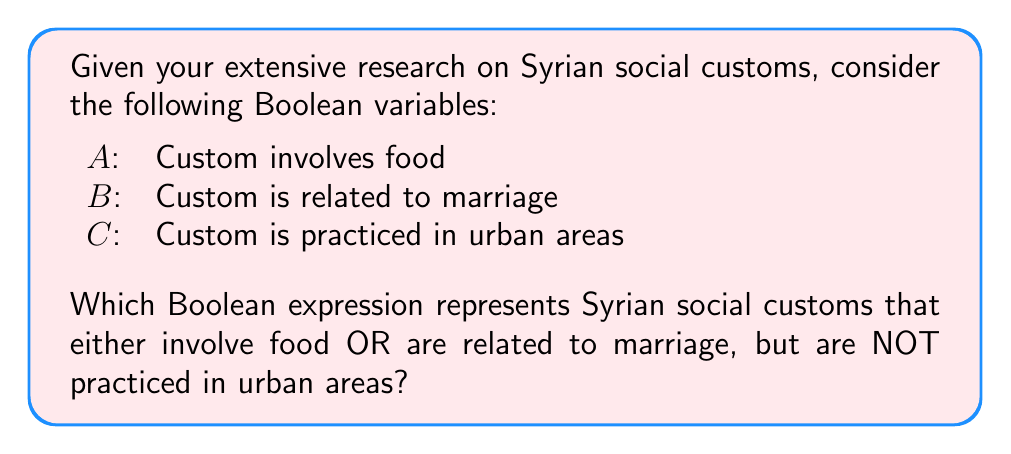Solve this math problem. Let's approach this step-by-step using Boolean algebra:

1) We need customs that involve food OR are related to marriage:
   This is represented by $(A \lor B)$

2) However, we don't want customs practiced in urban areas:
   This is represented by $\lnot C$ (NOT C)

3) We need to combine these conditions using AND:
   $$(A \lor B) \land \lnot C$$

4) This expression can be expanded using the distributive property:
   $$(A \land \lnot C) \lor (B \land \lnot C)$$

5) Interpretation:
   - $(A \land \lnot C)$ represents customs that involve food and are not practiced in urban areas
   - $(B \land \lnot C)$ represents customs related to marriage and not practiced in urban areas
   - The OR $\lor$ between these terms means we're including both types

This Boolean expression effectively classifies Syrian social customs that either involve food or are related to marriage, but are specifically not practiced in urban areas, aligning with your anthropological research focus.
Answer: $(A \lor B) \land \lnot C$ 